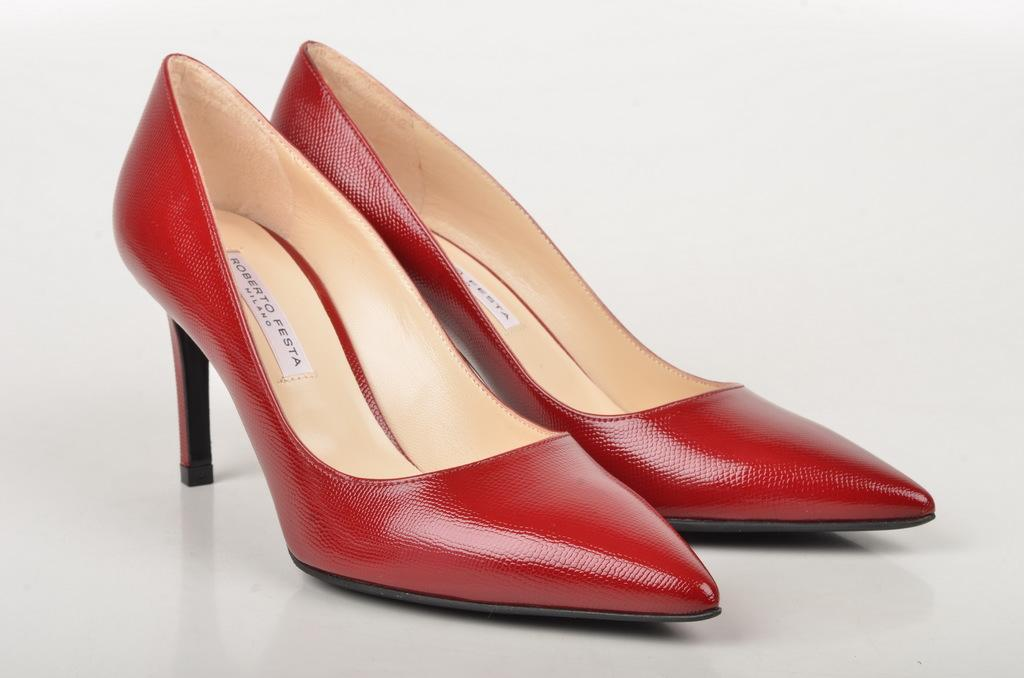What type of object can be seen in the image? There is footwear in the image. What color is the background of the image? The background of the image is white. What type of stem can be seen growing from the footwear in the image? There is no stem growing from the footwear in the image. What type of cloth is used to make the footwear in the image? The provided facts do not specify the type of material used to make the footwear. How many stitches can be seen on the footwear in the image? The provided facts do not specify the number of stitches on the footwear. 